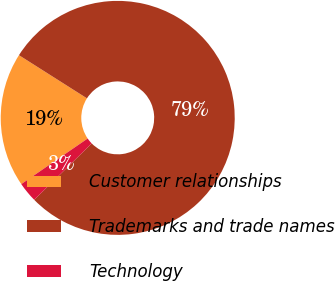Convert chart to OTSL. <chart><loc_0><loc_0><loc_500><loc_500><pie_chart><fcel>Customer relationships<fcel>Trademarks and trade names<fcel>Technology<nl><fcel>18.58%<fcel>78.65%<fcel>2.77%<nl></chart> 